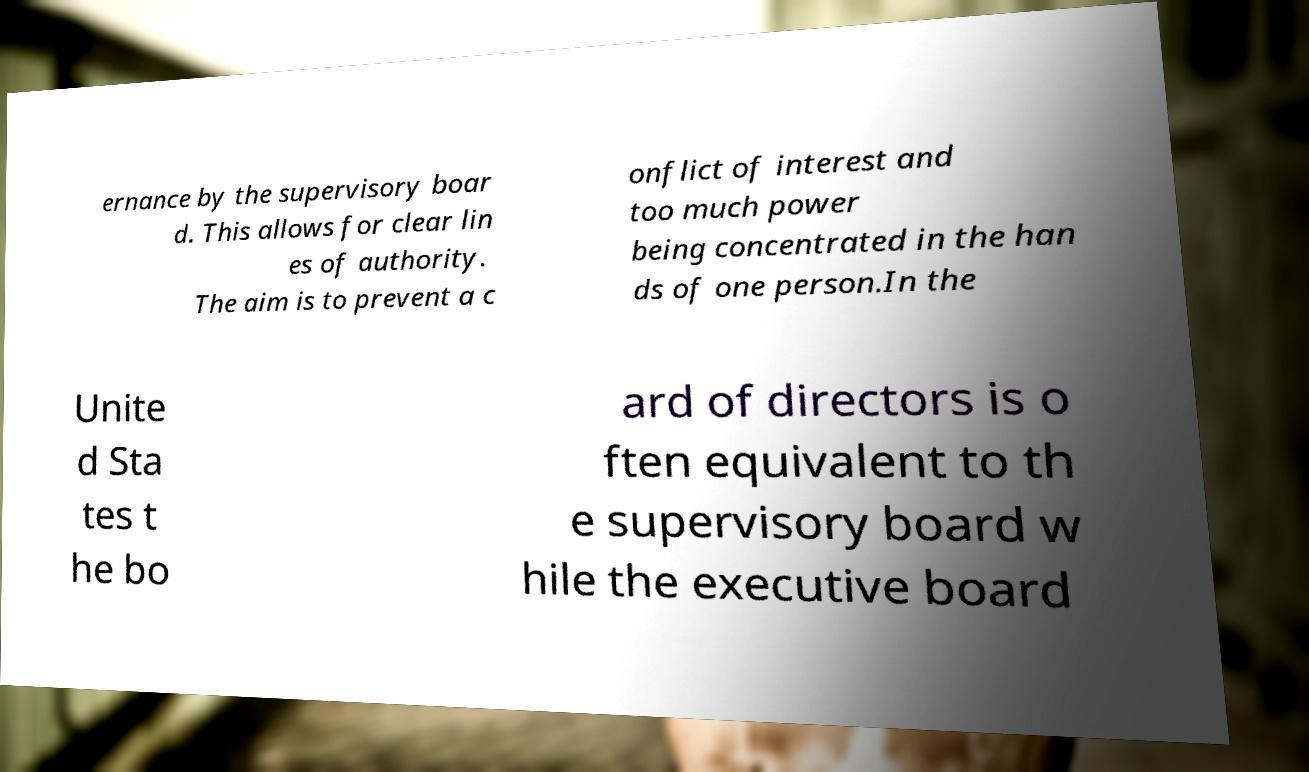For documentation purposes, I need the text within this image transcribed. Could you provide that? ernance by the supervisory boar d. This allows for clear lin es of authority. The aim is to prevent a c onflict of interest and too much power being concentrated in the han ds of one person.In the Unite d Sta tes t he bo ard of directors is o ften equivalent to th e supervisory board w hile the executive board 